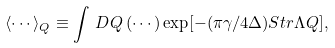Convert formula to latex. <formula><loc_0><loc_0><loc_500><loc_500>\langle \cdots \rangle _ { Q } \equiv \int \, D Q \, ( \cdots ) \exp [ - ( \pi \gamma / 4 \Delta ) S t r \Lambda Q ] ,</formula> 